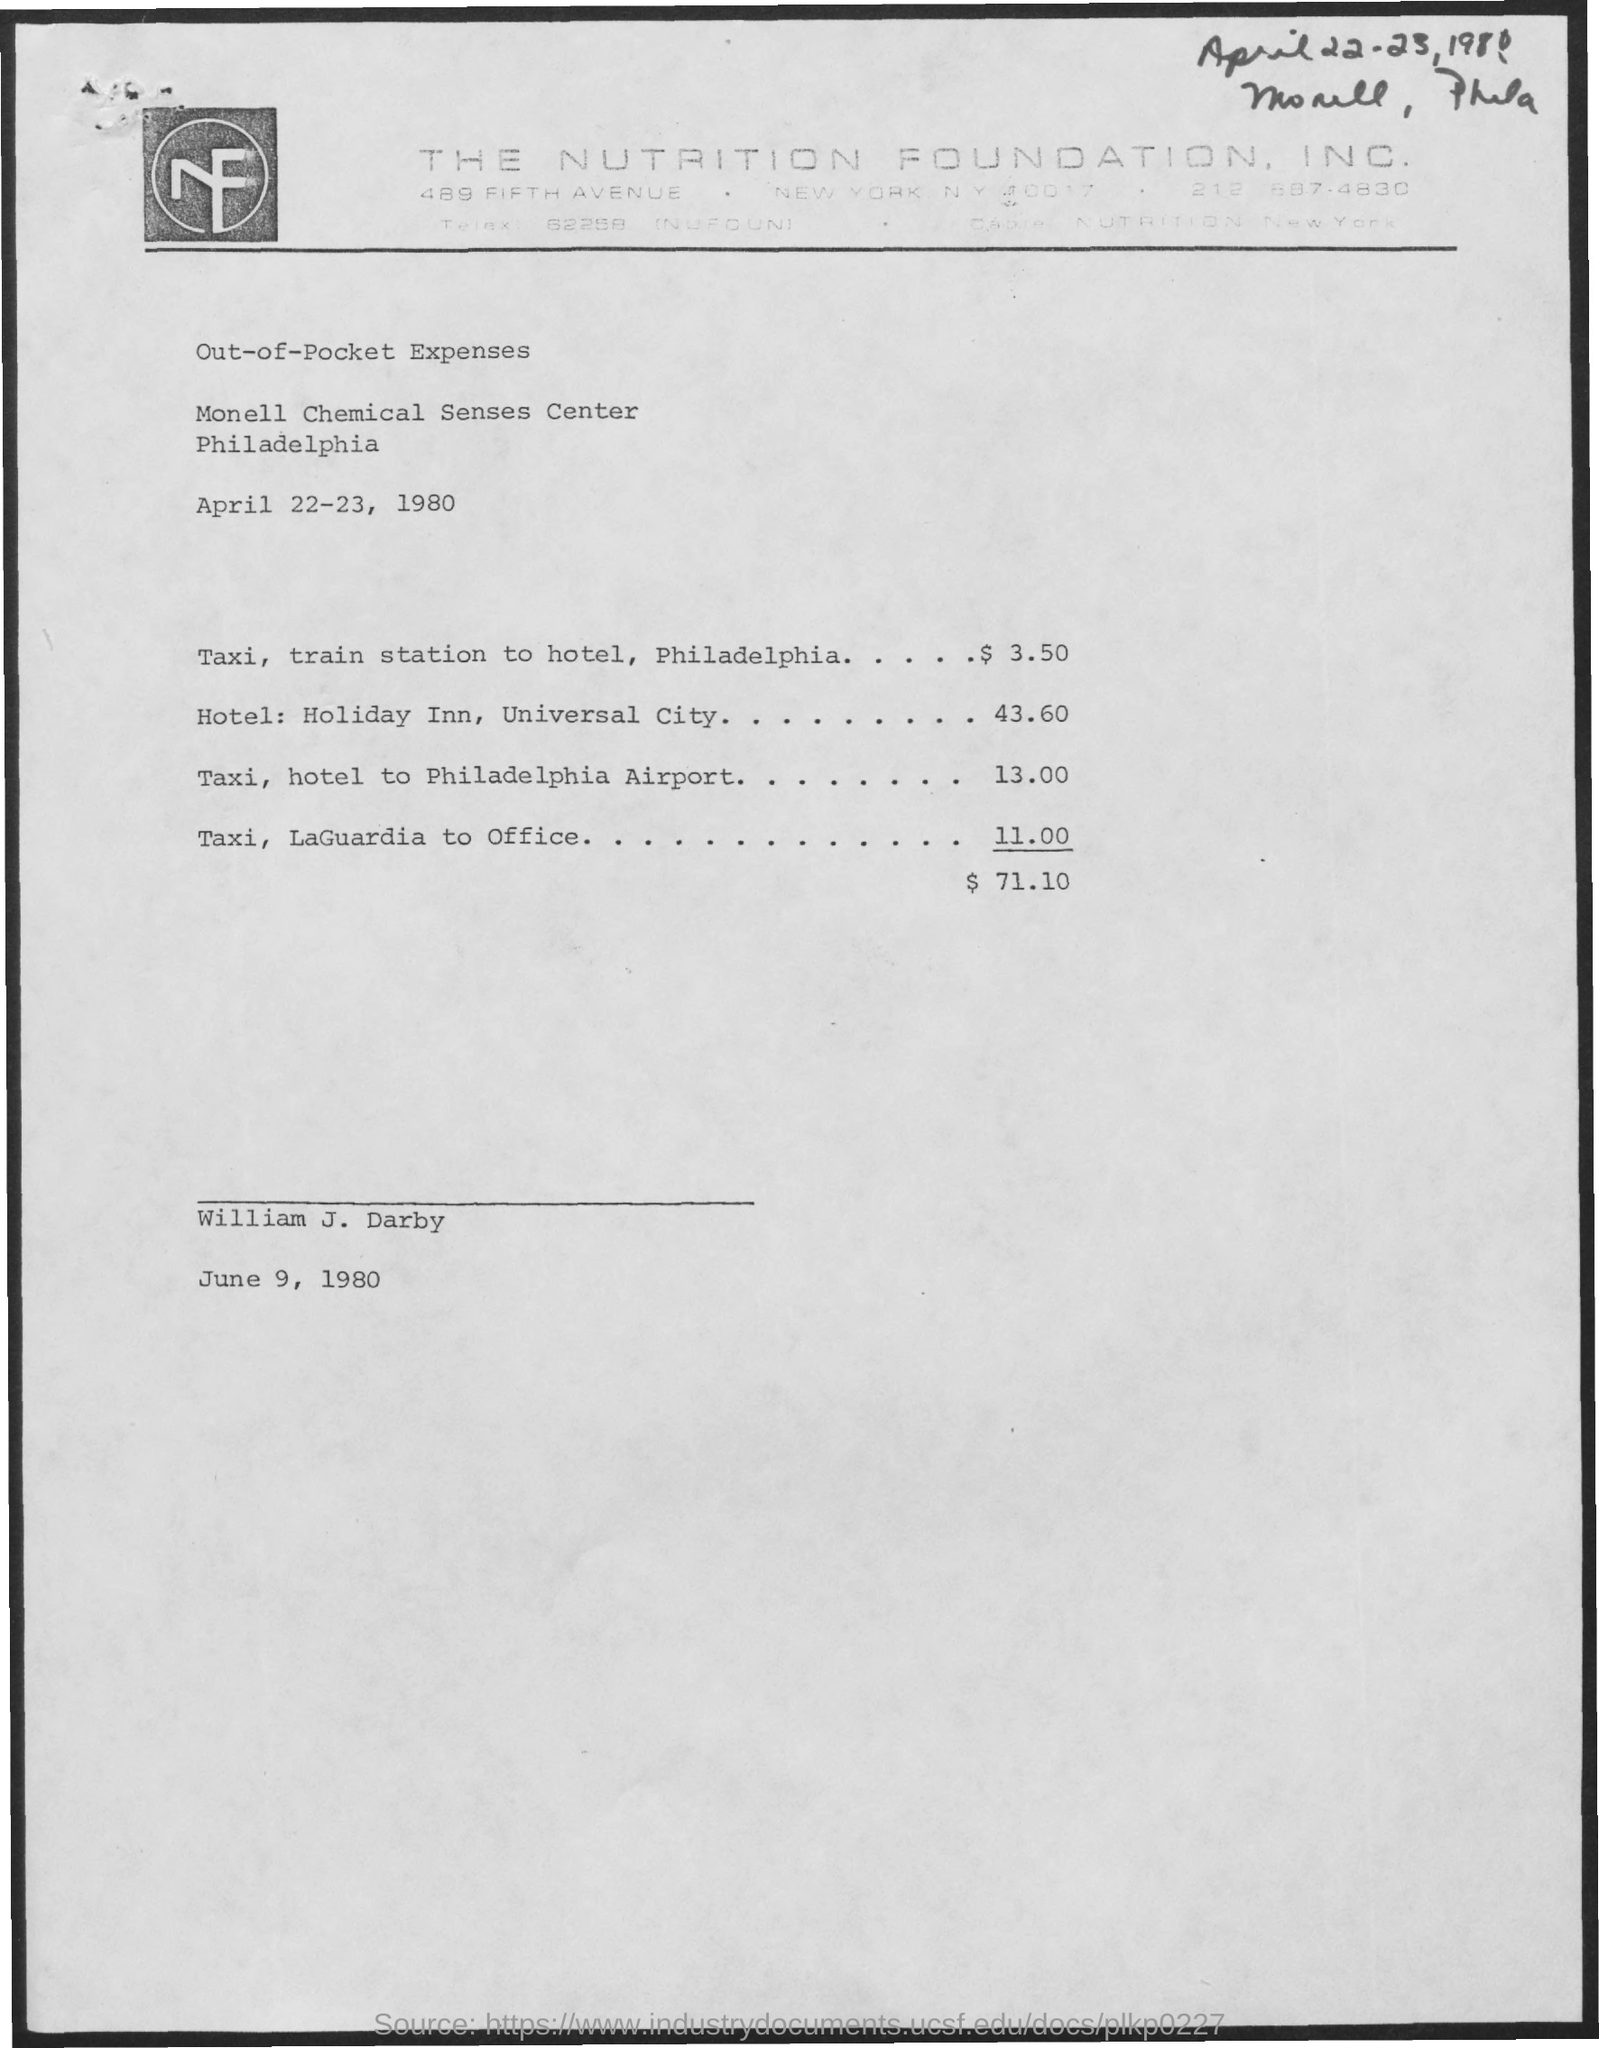For what period do these out-of- pocket expenses belong to?
Your response must be concise. April 22-23, 1980. Where is monell chemical senses center located at?
Ensure brevity in your answer.  Philadelphia. What is the amount for taxi, train station to hotel, philadelphia?
Provide a short and direct response. $ 3.50. What is the amount for hotel: holiday inn, universal city?
Offer a very short reply. $43.60. What is the amount for taxi, hotel to philadelphia airport?
Keep it short and to the point. $ 13.00. What is the amount for taxi, laguardia to office?
Provide a short and direct response. $11.00. What is the total amount of out of  pocket expenses?
Your answer should be very brief. $ 71.10. 